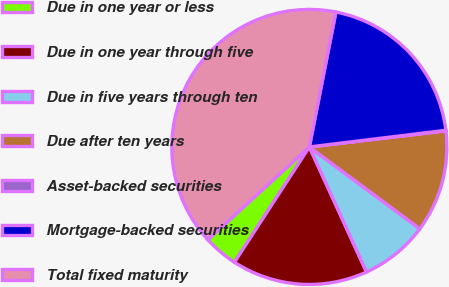Convert chart. <chart><loc_0><loc_0><loc_500><loc_500><pie_chart><fcel>Due in one year or less<fcel>Due in one year through five<fcel>Due in five years through ten<fcel>Due after ten years<fcel>Asset-backed securities<fcel>Mortgage-backed securities<fcel>Total fixed maturity<nl><fcel>4.05%<fcel>15.99%<fcel>8.03%<fcel>12.01%<fcel>0.07%<fcel>19.97%<fcel>39.87%<nl></chart> 